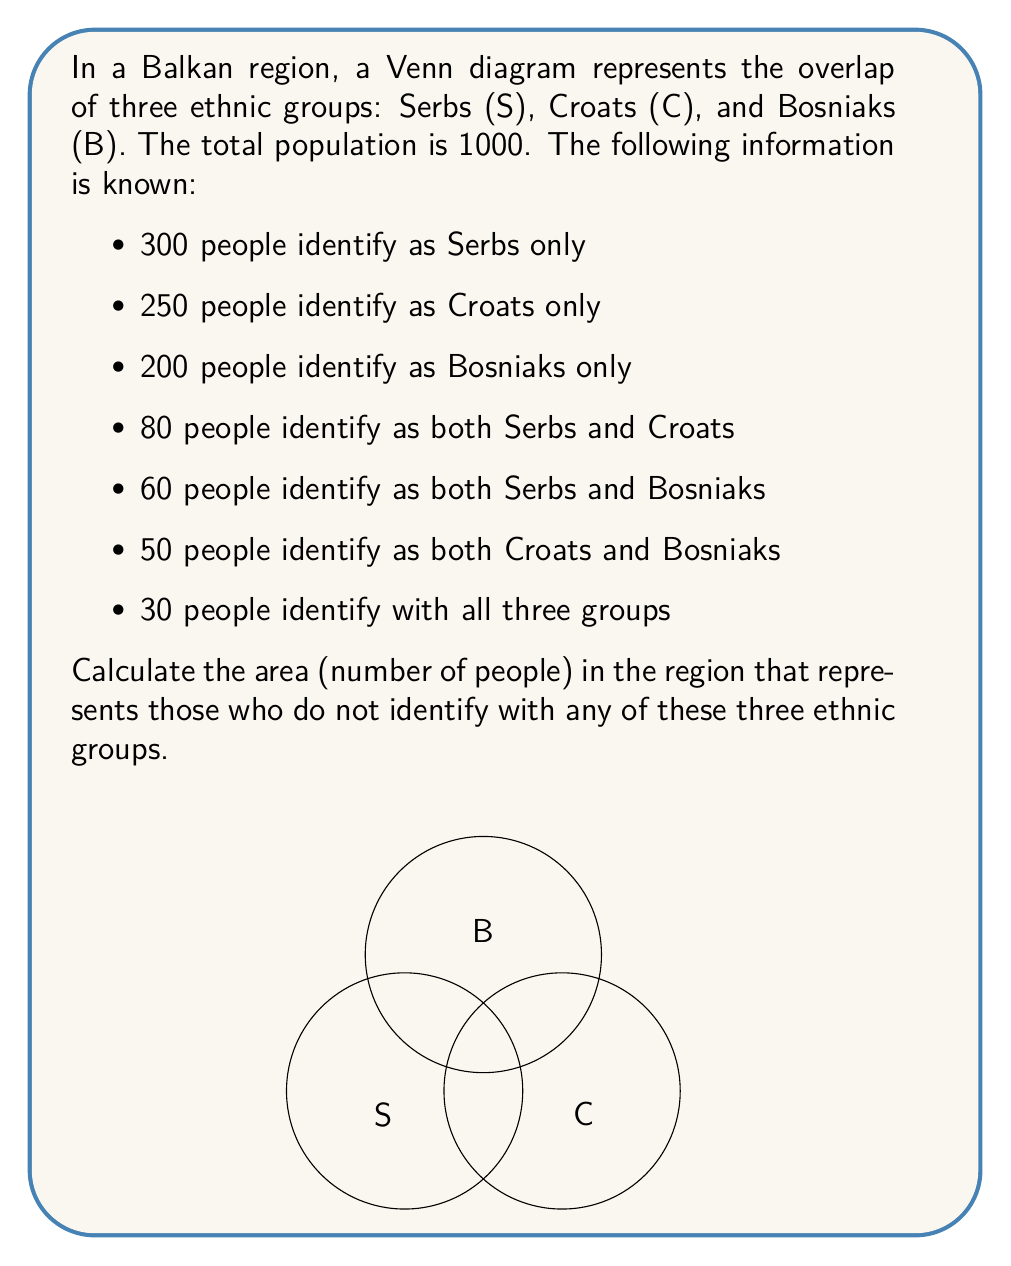Show me your answer to this math problem. Let's approach this step-by-step using the principle of inclusion-exclusion:

1) First, let's define our sets:
   $S$: Serbs, $C$: Croats, $B$: Bosniaks

2) We know the following:
   $|S| = 300 + 80 + 60 + 30 = 470$
   $|C| = 250 + 80 + 50 + 30 = 410$
   $|B| = 200 + 60 + 50 + 30 = 340$
   $|S \cap C| = 80 + 30 = 110$
   $|S \cap B| = 60 + 30 = 90$
   $|C \cap B| = 50 + 30 = 80$
   $|S \cap C \cap B| = 30$

3) The total number of people who identify with at least one group is:
   $|S \cup C \cup B| = |S| + |C| + |B| - |S \cap C| - |S \cap B| - |C \cap B| + |S \cap C \cap B|$

4) Substituting the values:
   $|S \cup C \cup B| = 470 + 410 + 340 - 110 - 90 - 80 + 30 = 970$

5) The number of people who don't identify with any group is:
   $1000 - 970 = 30$

Therefore, 30 people do not identify with any of the three ethnic groups.
Answer: 30 people 